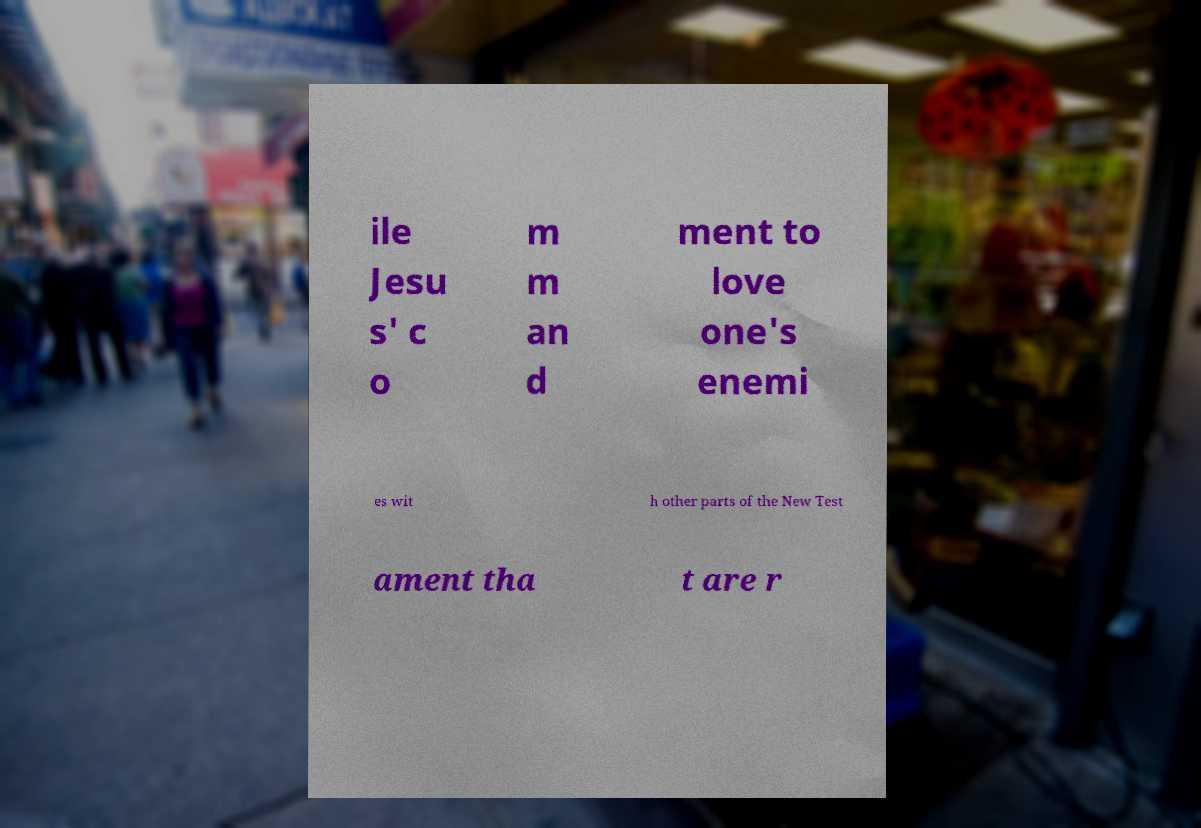What messages or text are displayed in this image? I need them in a readable, typed format. ile Jesu s' c o m m an d ment to love one's enemi es wit h other parts of the New Test ament tha t are r 